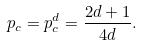<formula> <loc_0><loc_0><loc_500><loc_500>p _ { c } = p _ { c } ^ { d } = \frac { 2 d + 1 } { 4 d } .</formula> 